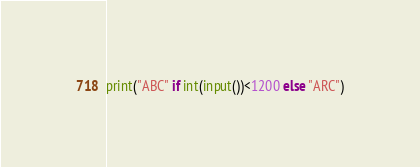Convert code to text. <code><loc_0><loc_0><loc_500><loc_500><_Python_>print("ABC" if int(input())<1200 else "ARC")</code> 